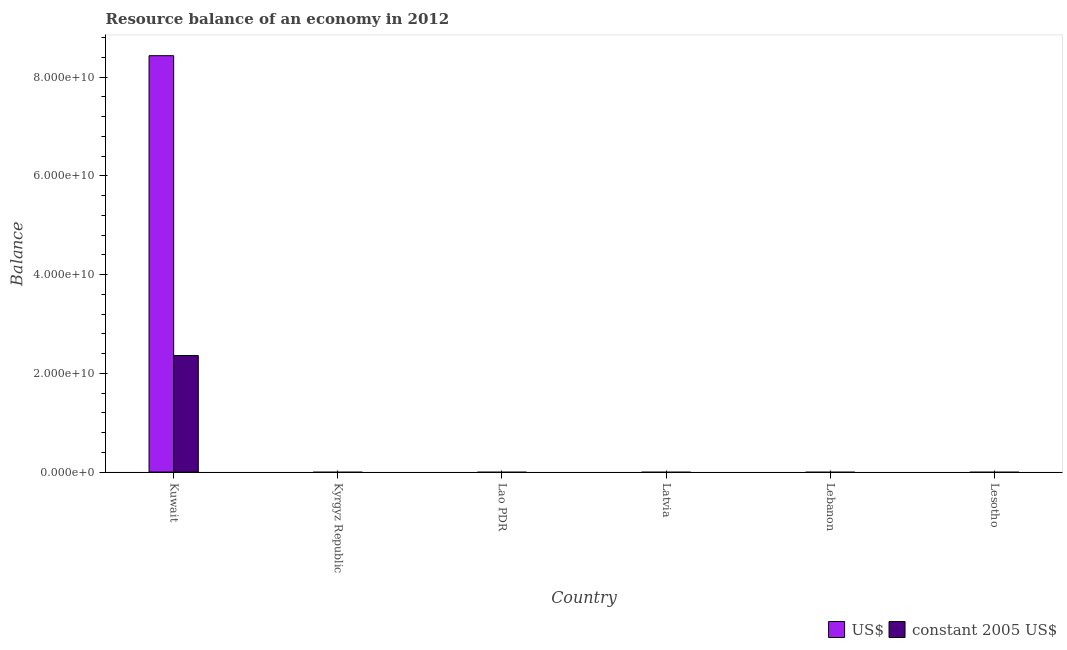How many different coloured bars are there?
Offer a very short reply. 2. Are the number of bars per tick equal to the number of legend labels?
Provide a succinct answer. No. Are the number of bars on each tick of the X-axis equal?
Provide a short and direct response. No. How many bars are there on the 1st tick from the right?
Your response must be concise. 0. What is the label of the 6th group of bars from the left?
Keep it short and to the point. Lesotho. What is the resource balance in constant us$ in Lesotho?
Offer a very short reply. 0. Across all countries, what is the maximum resource balance in us$?
Your response must be concise. 8.43e+1. In which country was the resource balance in constant us$ maximum?
Make the answer very short. Kuwait. What is the total resource balance in us$ in the graph?
Give a very brief answer. 8.43e+1. What is the difference between the resource balance in constant us$ in Lebanon and the resource balance in us$ in Kuwait?
Provide a short and direct response. -8.43e+1. What is the average resource balance in us$ per country?
Your answer should be compact. 1.41e+1. What is the difference between the resource balance in us$ and resource balance in constant us$ in Kuwait?
Your response must be concise. 6.07e+1. What is the difference between the highest and the lowest resource balance in us$?
Offer a very short reply. 8.43e+1. How many bars are there?
Make the answer very short. 2. Are the values on the major ticks of Y-axis written in scientific E-notation?
Keep it short and to the point. Yes. Does the graph contain any zero values?
Keep it short and to the point. Yes. Where does the legend appear in the graph?
Your answer should be compact. Bottom right. How many legend labels are there?
Ensure brevity in your answer.  2. How are the legend labels stacked?
Your answer should be very brief. Horizontal. What is the title of the graph?
Ensure brevity in your answer.  Resource balance of an economy in 2012. What is the label or title of the Y-axis?
Your answer should be very brief. Balance. What is the Balance of US$ in Kuwait?
Offer a terse response. 8.43e+1. What is the Balance in constant 2005 US$ in Kuwait?
Provide a short and direct response. 2.36e+1. What is the Balance in constant 2005 US$ in Kyrgyz Republic?
Offer a very short reply. 0. What is the Balance in constant 2005 US$ in Lao PDR?
Provide a short and direct response. 0. What is the Balance of constant 2005 US$ in Lebanon?
Give a very brief answer. 0. Across all countries, what is the maximum Balance in US$?
Your response must be concise. 8.43e+1. Across all countries, what is the maximum Balance in constant 2005 US$?
Make the answer very short. 2.36e+1. Across all countries, what is the minimum Balance of US$?
Give a very brief answer. 0. What is the total Balance in US$ in the graph?
Provide a succinct answer. 8.43e+1. What is the total Balance of constant 2005 US$ in the graph?
Offer a very short reply. 2.36e+1. What is the average Balance of US$ per country?
Offer a terse response. 1.41e+1. What is the average Balance of constant 2005 US$ per country?
Make the answer very short. 3.93e+09. What is the difference between the Balance in US$ and Balance in constant 2005 US$ in Kuwait?
Offer a terse response. 6.07e+1. What is the difference between the highest and the lowest Balance of US$?
Give a very brief answer. 8.43e+1. What is the difference between the highest and the lowest Balance in constant 2005 US$?
Provide a succinct answer. 2.36e+1. 